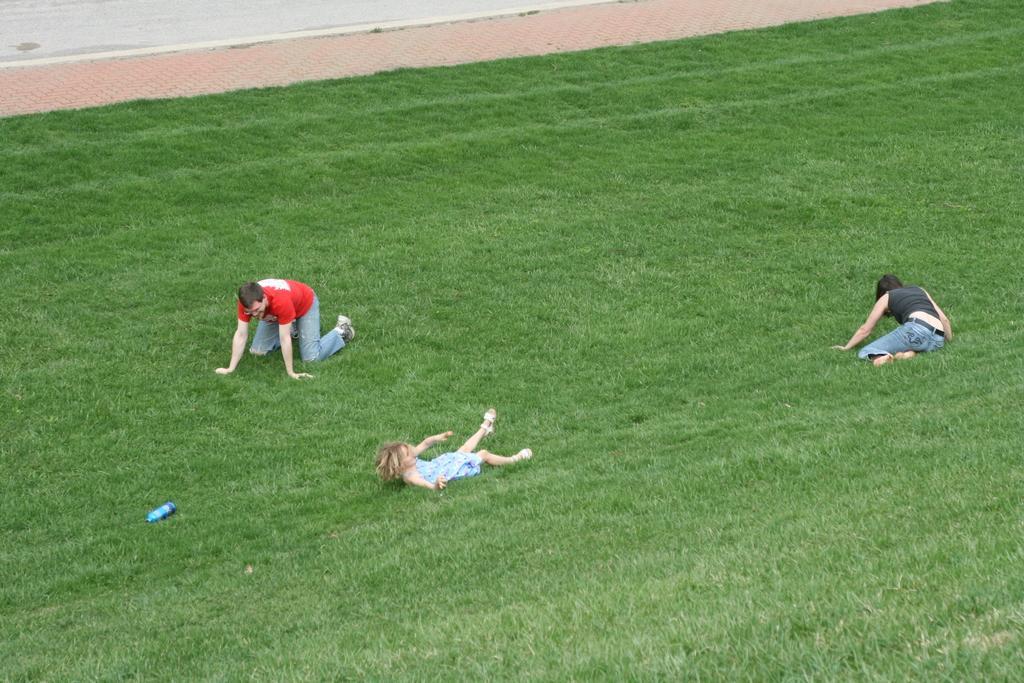How would you summarize this image in a sentence or two? In this picture we can see few people and a bottle on the grass. 